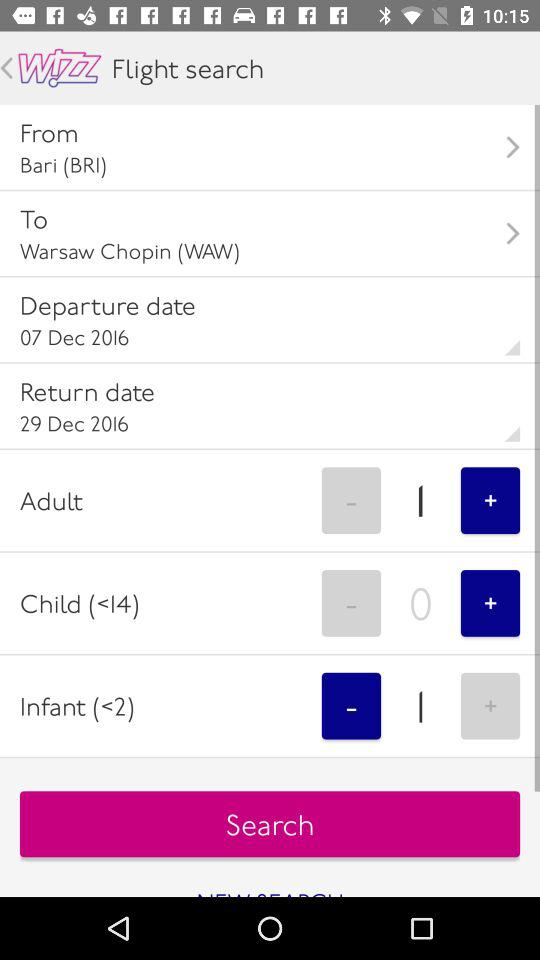What is the departure location? The departure location is Bari (BRI). 